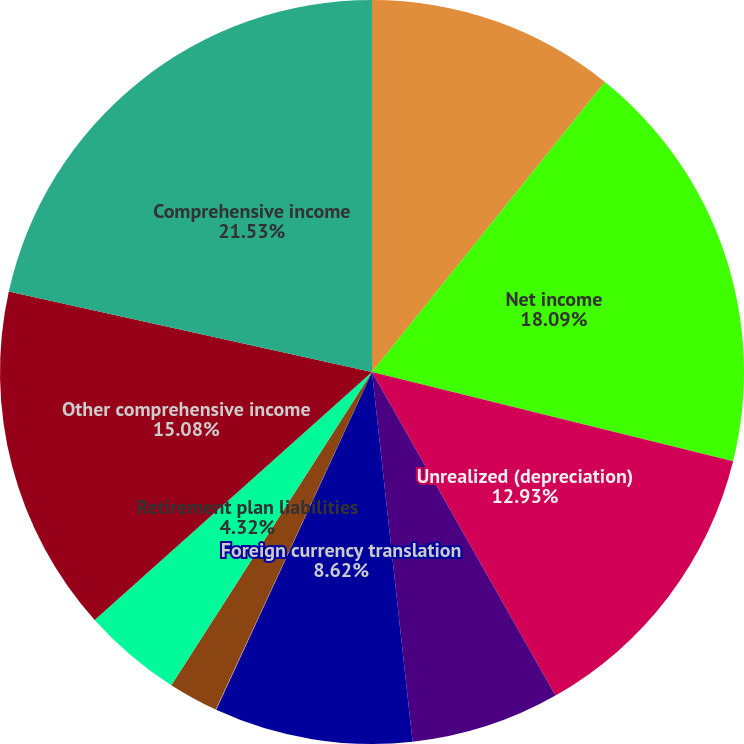Convert chart to OTSL. <chart><loc_0><loc_0><loc_500><loc_500><pie_chart><fcel>Years Ended December 31 (in<fcel>Net income<fcel>Unrealized (depreciation)<fcel>Deferred income tax benefit<fcel>Foreign currency translation<fcel>Net derivative gains arising<fcel>Deferred income tax expense on<fcel>Retirement plan liabilities<fcel>Other comprehensive income<fcel>Comprehensive income<nl><fcel>10.77%<fcel>18.09%<fcel>12.93%<fcel>6.47%<fcel>8.62%<fcel>0.02%<fcel>2.17%<fcel>4.32%<fcel>15.08%<fcel>21.53%<nl></chart> 